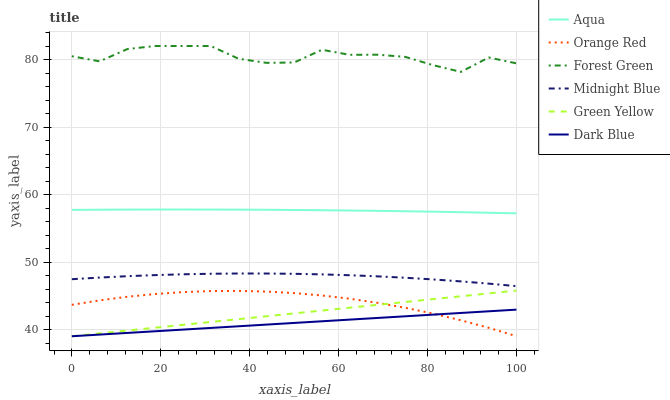Does Dark Blue have the minimum area under the curve?
Answer yes or no. Yes. Does Forest Green have the maximum area under the curve?
Answer yes or no. Yes. Does Aqua have the minimum area under the curve?
Answer yes or no. No. Does Aqua have the maximum area under the curve?
Answer yes or no. No. Is Dark Blue the smoothest?
Answer yes or no. Yes. Is Forest Green the roughest?
Answer yes or no. Yes. Is Aqua the smoothest?
Answer yes or no. No. Is Aqua the roughest?
Answer yes or no. No. Does Dark Blue have the lowest value?
Answer yes or no. Yes. Does Aqua have the lowest value?
Answer yes or no. No. Does Forest Green have the highest value?
Answer yes or no. Yes. Does Aqua have the highest value?
Answer yes or no. No. Is Midnight Blue less than Aqua?
Answer yes or no. Yes. Is Midnight Blue greater than Orange Red?
Answer yes or no. Yes. Does Orange Red intersect Green Yellow?
Answer yes or no. Yes. Is Orange Red less than Green Yellow?
Answer yes or no. No. Is Orange Red greater than Green Yellow?
Answer yes or no. No. Does Midnight Blue intersect Aqua?
Answer yes or no. No. 